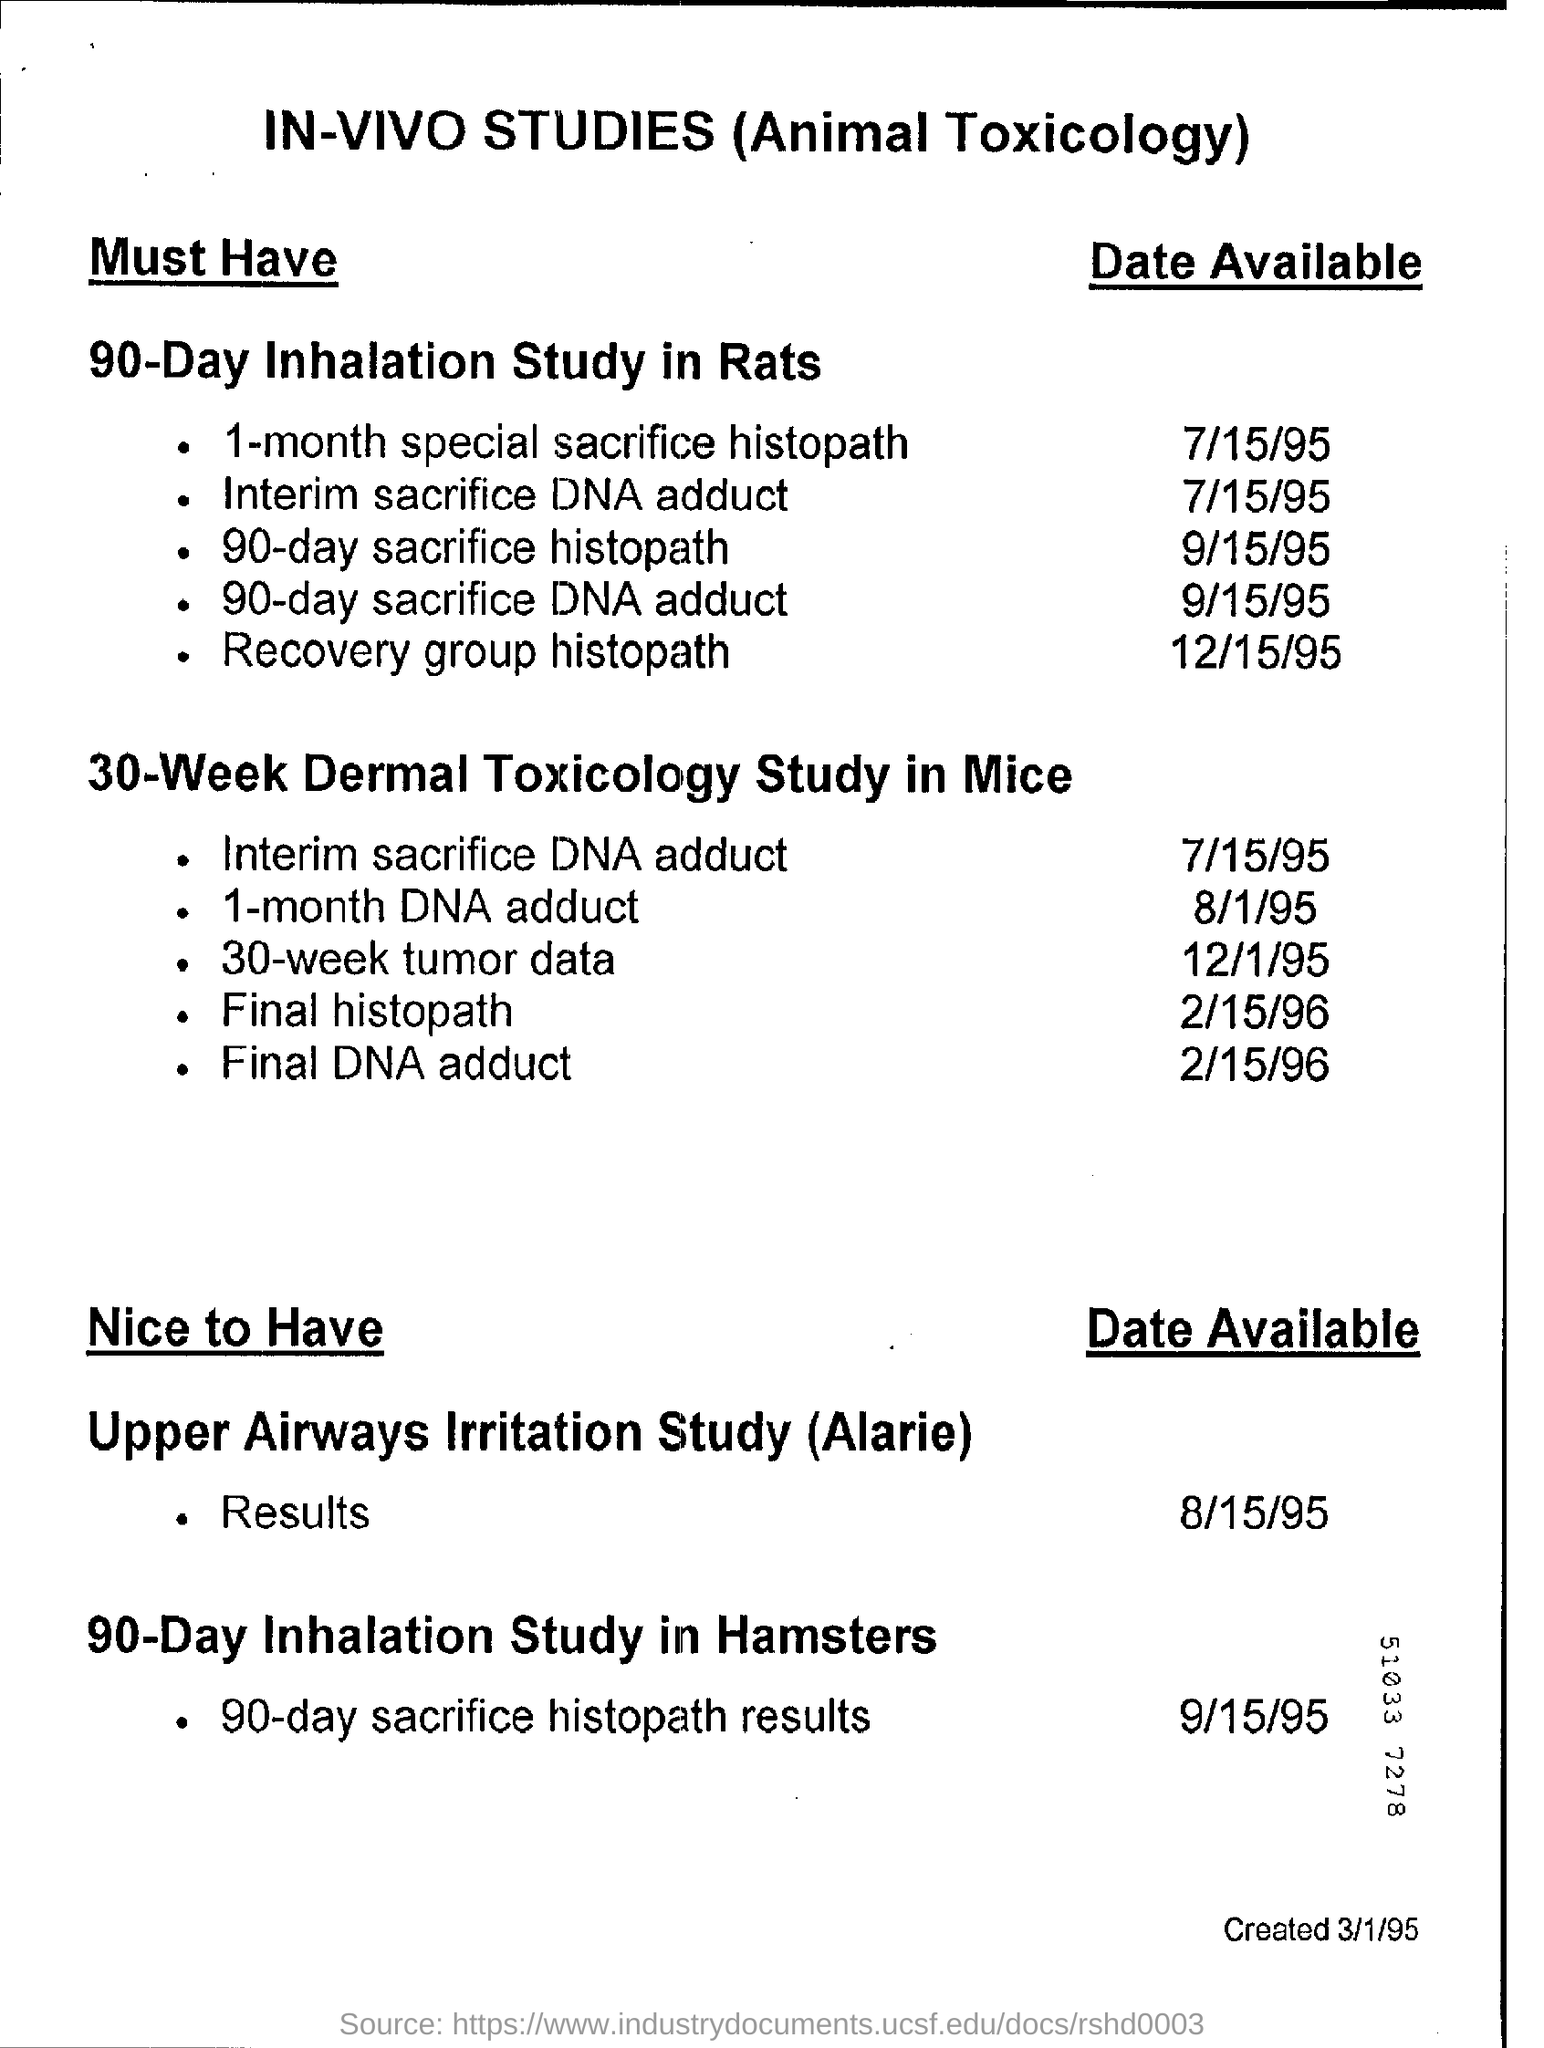What is the heading at top of the page ?
Your answer should be very brief. In-vivo studies (animal toxicology). What is the date available for " 1- month special sacrifice histopath "?
Make the answer very short. 7/15/95. 